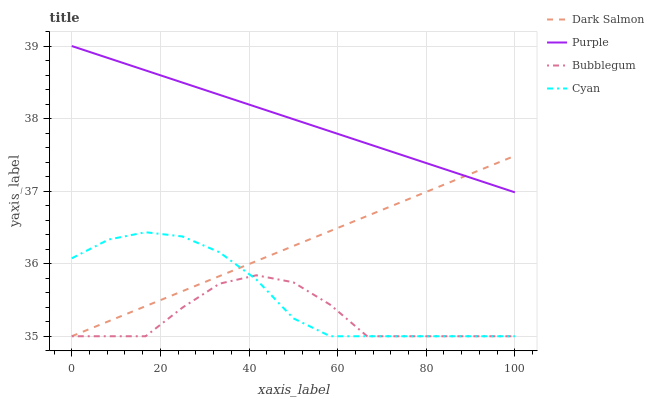Does Cyan have the minimum area under the curve?
Answer yes or no. No. Does Cyan have the maximum area under the curve?
Answer yes or no. No. Is Cyan the smoothest?
Answer yes or no. No. Is Cyan the roughest?
Answer yes or no. No. Does Cyan have the highest value?
Answer yes or no. No. Is Bubblegum less than Purple?
Answer yes or no. Yes. Is Purple greater than Cyan?
Answer yes or no. Yes. Does Bubblegum intersect Purple?
Answer yes or no. No. 